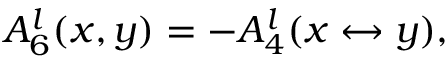<formula> <loc_0><loc_0><loc_500><loc_500>A _ { 6 } ^ { l } ( x , y ) = - A _ { 4 } ^ { l } ( x \leftrightarrow y ) ,</formula> 